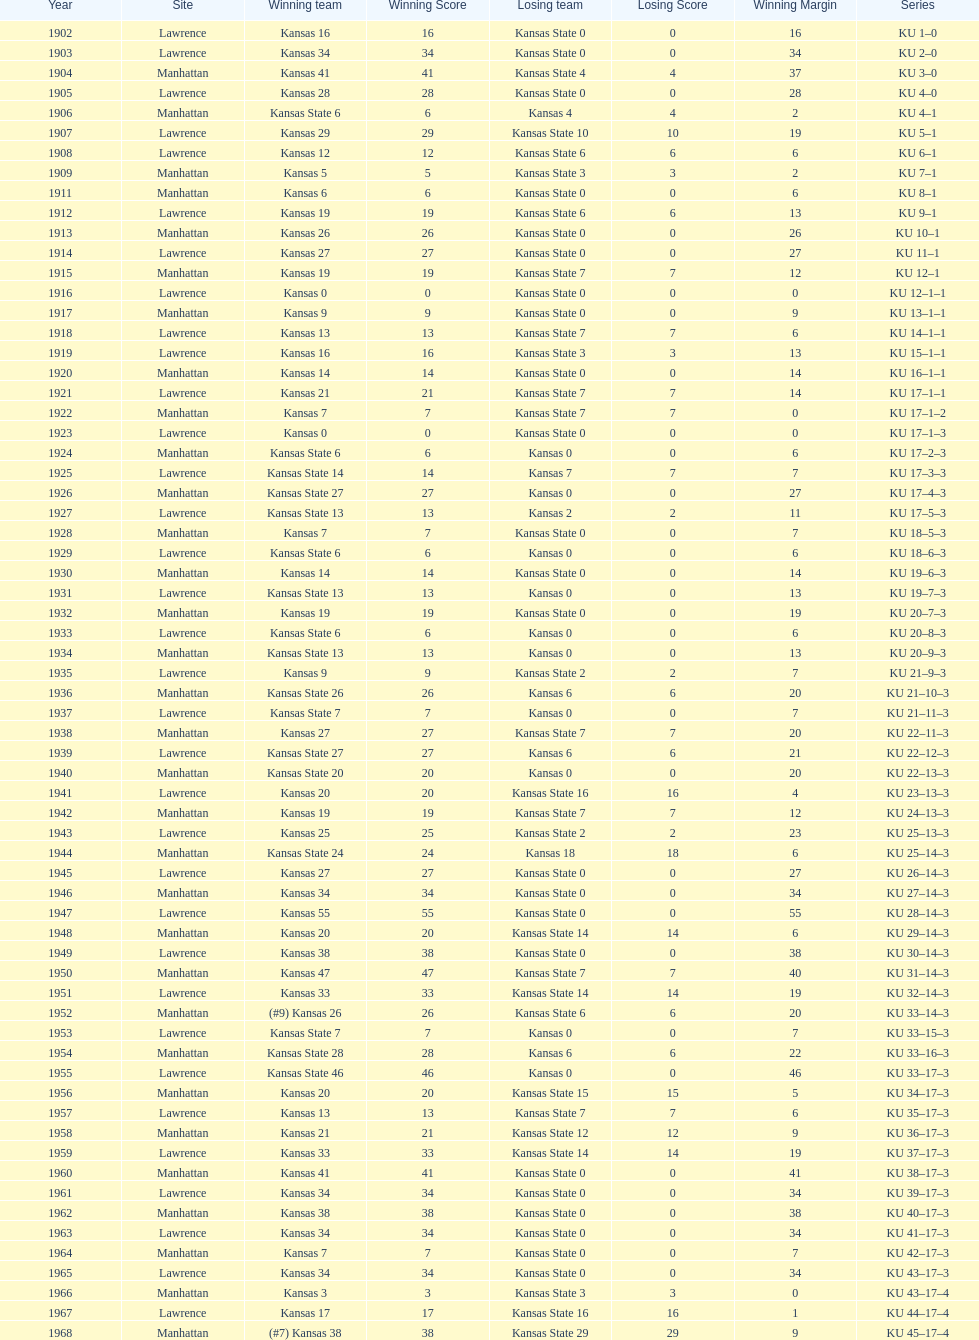When was the first game that kansas state won by double digits? 1926. 